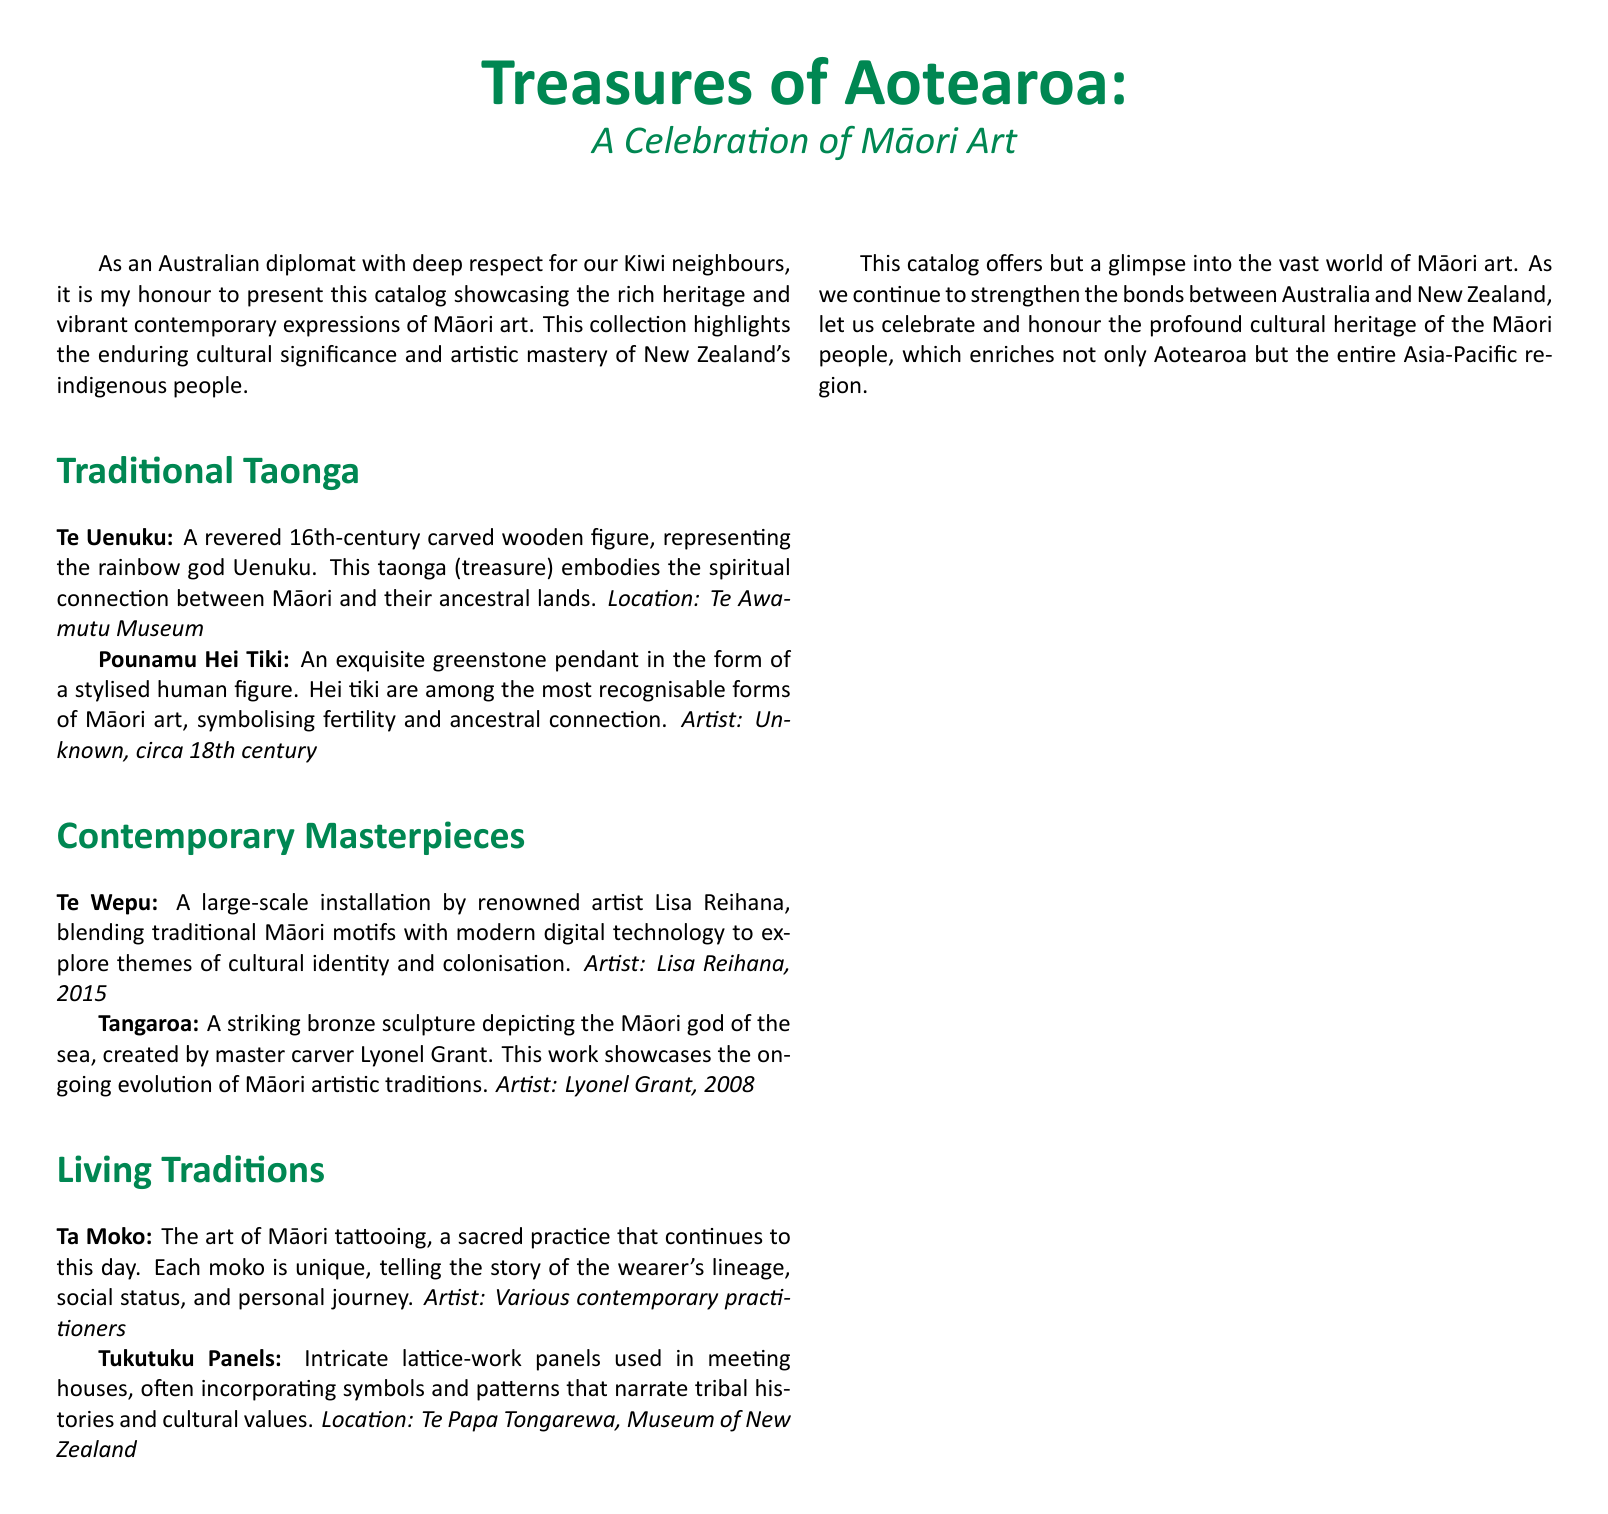What is the title of the catalog? The title of the catalog is presented prominently at the beginning of the document.
Answer: Treasures of Aotearoa Who created the sculpture Tangaroa? The document specifies the artist who created the sculpture Tangaroa.
Answer: Lyonel Grant In what year was Te Wepu created? The document lists the year of creation for the artwork Te Wepu.
Answer: 2015 What is the form of the Pounamu Hei Tiki pendant? The description of Pounamu Hei Tiki reveals its form and significance.
Answer: Stylised human figure Which Māori art form tells the story of lineage and personal journey? The document provides a cultural description of this specific art form.
Answer: Ta Moko Where can the Tukutuku Panels be found? The document states the specific location for the Tukutuku Panels.
Answer: Te Papa Tongarewa, Museum of New Zealand What theme does Te Wepu explore? The document provides insights into the themes explored by the artwork Te Wepu.
Answer: Cultural identity and colonisation Which century does Te Uenuku originate from? The document mentions the century of origin for the carved wooden figure Te Uenuku.
Answer: 16th century 